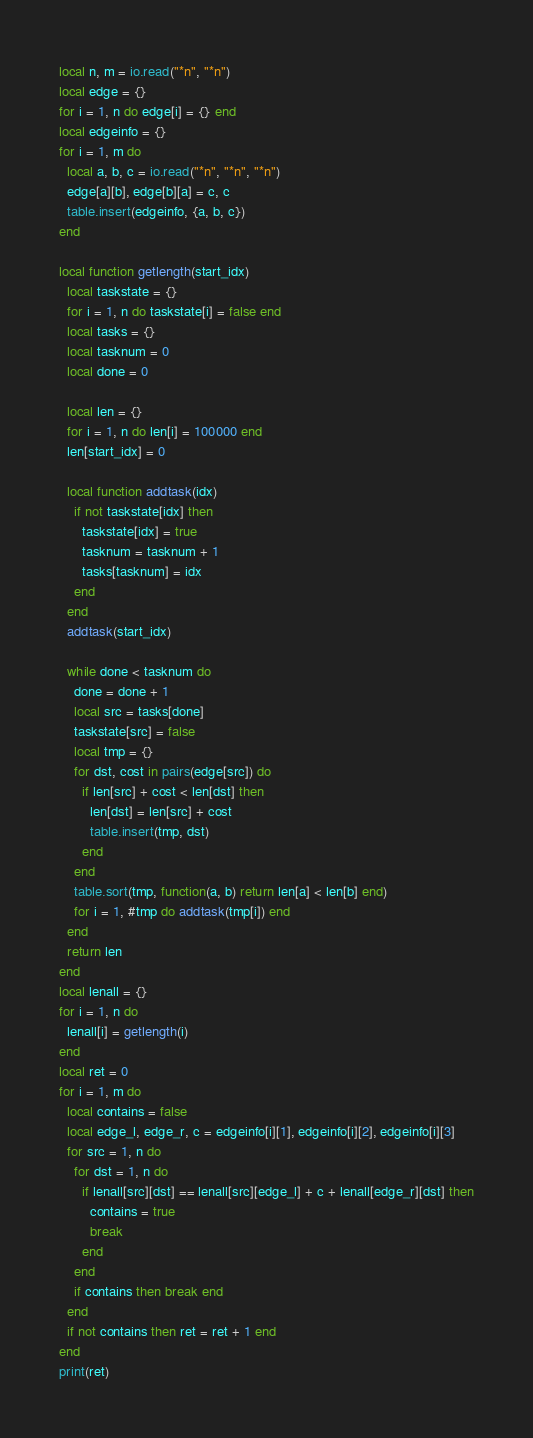<code> <loc_0><loc_0><loc_500><loc_500><_Lua_>local n, m = io.read("*n", "*n")
local edge = {}
for i = 1, n do edge[i] = {} end
local edgeinfo = {}
for i = 1, m do
  local a, b, c = io.read("*n", "*n", "*n")
  edge[a][b], edge[b][a] = c, c
  table.insert(edgeinfo, {a, b, c})
end

local function getlength(start_idx)
  local taskstate = {}
  for i = 1, n do taskstate[i] = false end
  local tasks = {}
  local tasknum = 0
  local done = 0

  local len = {}
  for i = 1, n do len[i] = 100000 end
  len[start_idx] = 0

  local function addtask(idx)
    if not taskstate[idx] then
      taskstate[idx] = true
      tasknum = tasknum + 1
      tasks[tasknum] = idx
    end
  end
  addtask(start_idx)

  while done < tasknum do
    done = done + 1
    local src = tasks[done]
    taskstate[src] = false
    local tmp = {}
    for dst, cost in pairs(edge[src]) do
      if len[src] + cost < len[dst] then
        len[dst] = len[src] + cost
        table.insert(tmp, dst)
      end
    end
    table.sort(tmp, function(a, b) return len[a] < len[b] end)
    for i = 1, #tmp do addtask(tmp[i]) end
  end
  return len
end
local lenall = {}
for i = 1, n do
  lenall[i] = getlength(i)
end
local ret = 0
for i = 1, m do
  local contains = false
  local edge_l, edge_r, c = edgeinfo[i][1], edgeinfo[i][2], edgeinfo[i][3]
  for src = 1, n do
    for dst = 1, n do
      if lenall[src][dst] == lenall[src][edge_l] + c + lenall[edge_r][dst] then
        contains = true
        break
      end
    end
    if contains then break end
  end
  if not contains then ret = ret + 1 end
end
print(ret)
</code> 